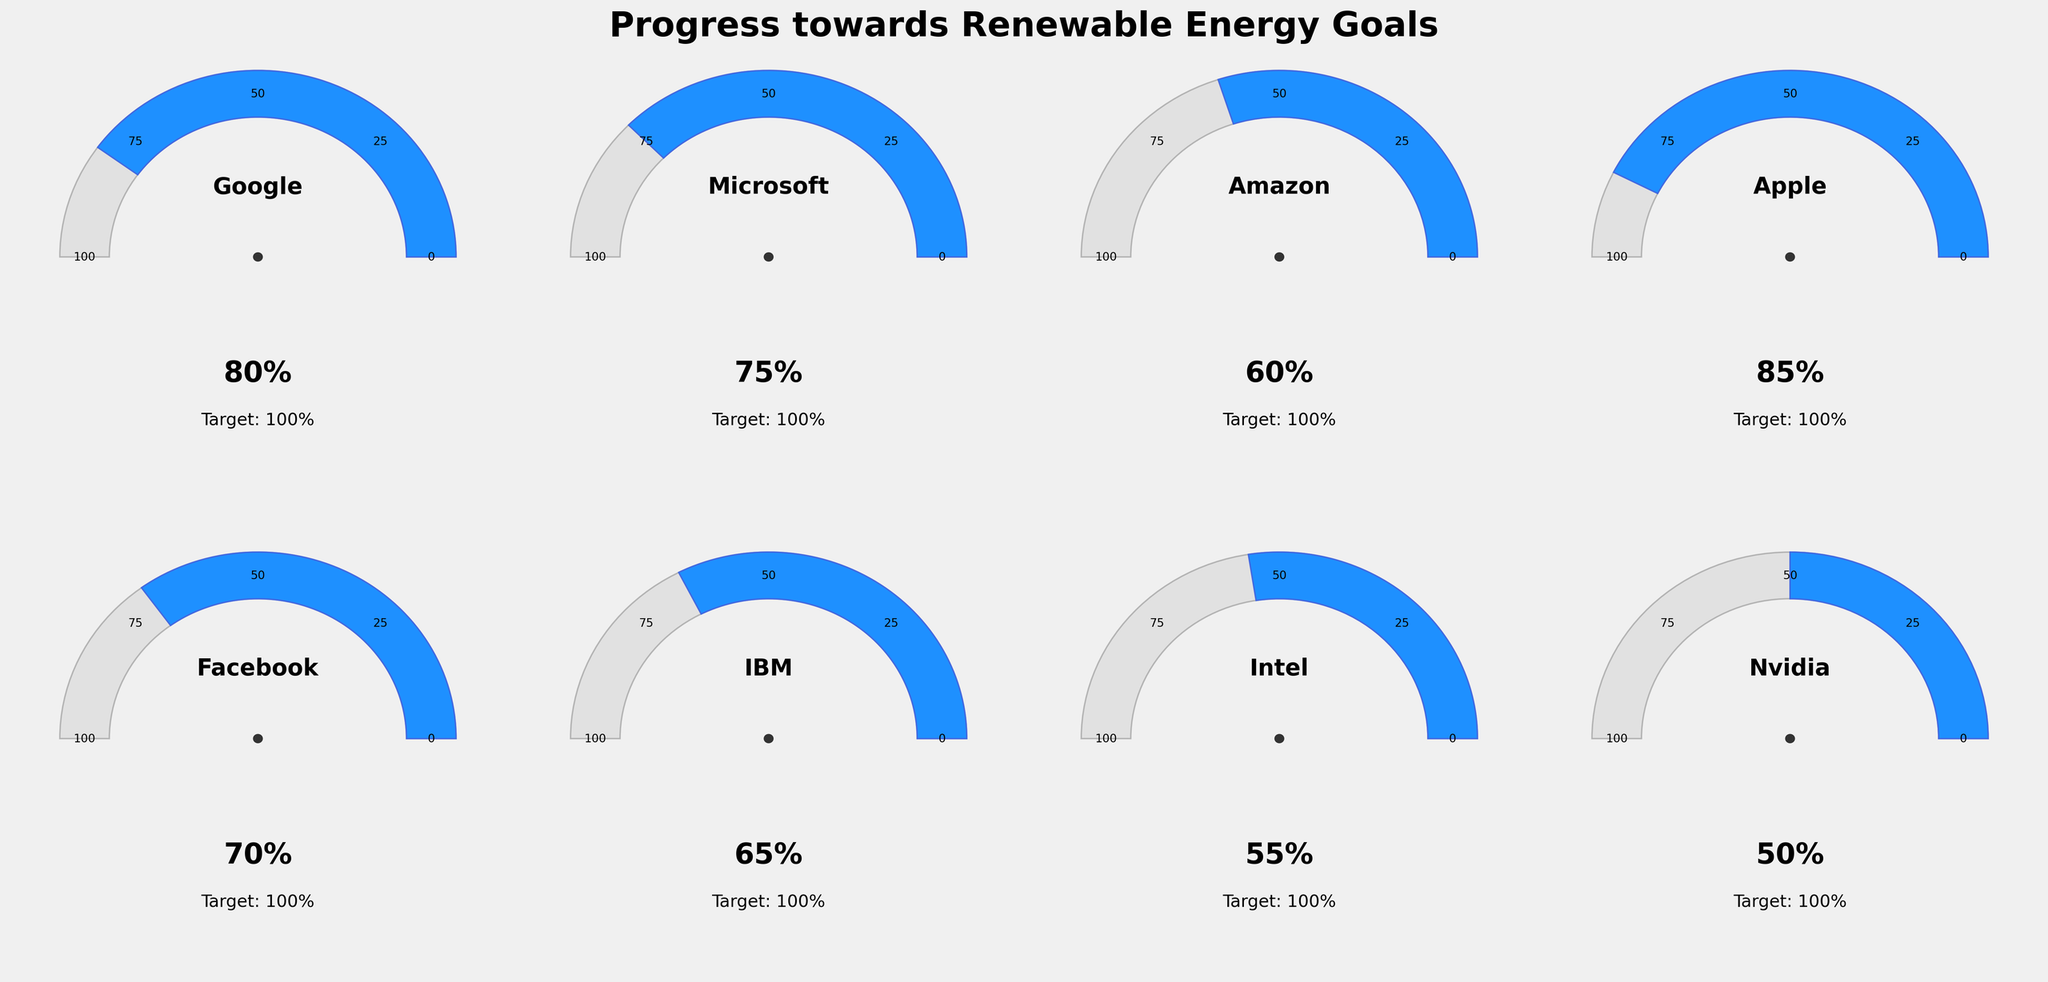What is the highest progress percentage towards renewable energy goals? The gauge chart shows progress percentages for different companies. Apple has the highest progress percentage of 85%.
Answer: 85% Which company has the lowest progress towards its renewable energy goal? The gauge chart provides progress percentages for each company. Nvidia has the lowest progress at 50%.
Answer: Nvidia What is the average progress percentage of all companies towards their renewable energy goal? To find the average, sum the progress percentages and divide by the number of companies. (80 + 75 + 60 + 85 + 70 + 65 + 55 + 50) / 8 = 67.5%.
Answer: 67.5% Between Google and Microsoft, which company has made more progress toward its renewable energy goal and by how much? Google has a progress of 80% and Microsoft has 75%. The difference is 80% - 75% = 5%.
Answer: Google, 5% How many companies have achieved at least 70% of their renewable energy goals? The companies achieving at least 70% are Google (80%), Microsoft (75%), Apple (85%), and Facebook (70%).
Answer: 4 What is the sum of progress percentages for Amazon, IBM, and Intel? Add the progress percentages for Amazon (60%), IBM (65%), and Intel (55%). 60% + 65% + 55% = 180%.
Answer: 180% If Apple's progress is compared to Intel's, how much more progress has Apple made? Apple has a progress of 85%, and Intel has 55%. The difference is 85% - 55% = 30%.
Answer: 30% Which companies have a progress percentage between 60% and 80%? The companies in this range are Amazon (60%), Facebook (70%), IBM (65%), and Microsoft (75%).
Answer: Amazon, Facebook, IBM, Microsoft Is there a company with an identical progress percentage to the next nearest whole number tick shown on the gauge chart? Yes, Facebook has a progress percentage of 70%, which is one of the ticks on the gauge chart (25, 50, 75, 100).
Answer: Facebook 